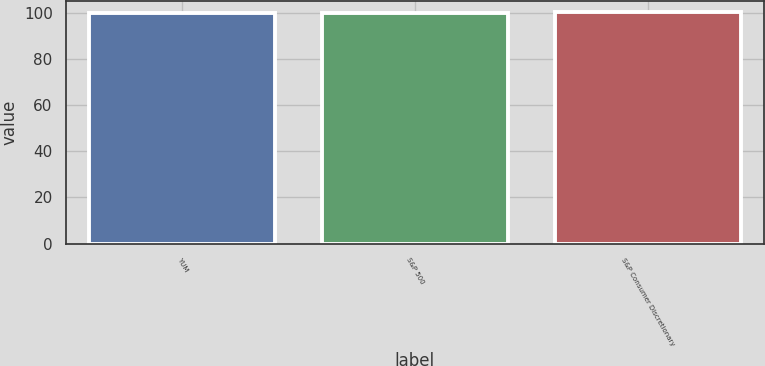<chart> <loc_0><loc_0><loc_500><loc_500><bar_chart><fcel>YUM<fcel>S&P 500<fcel>S&P Consumer Discretionary<nl><fcel>100<fcel>100.1<fcel>100.2<nl></chart> 